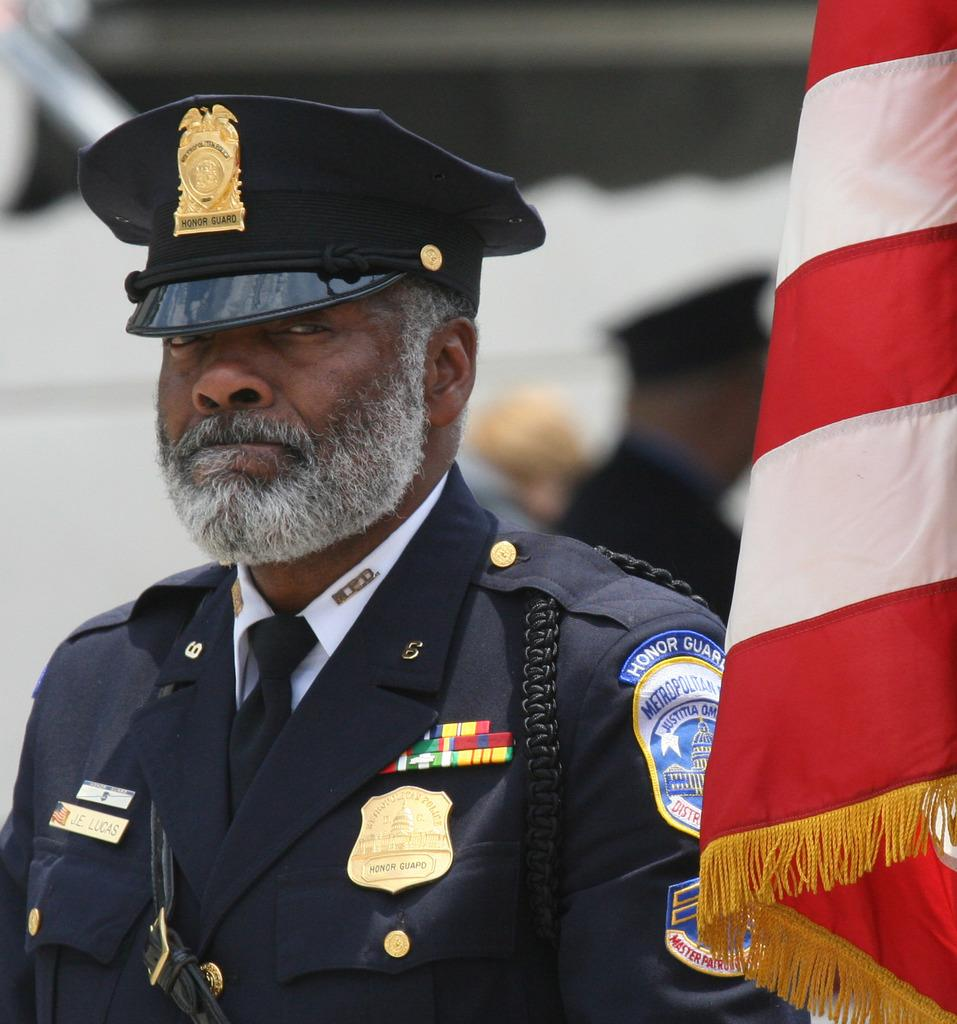Who is present in the image? There is a man in the image. What can be seen on the right side of the image? There is a flag on the right side of the image. What type of pig can be seen interacting with the man in the image? There is no pig present in the image; it only features a man and a flag. 